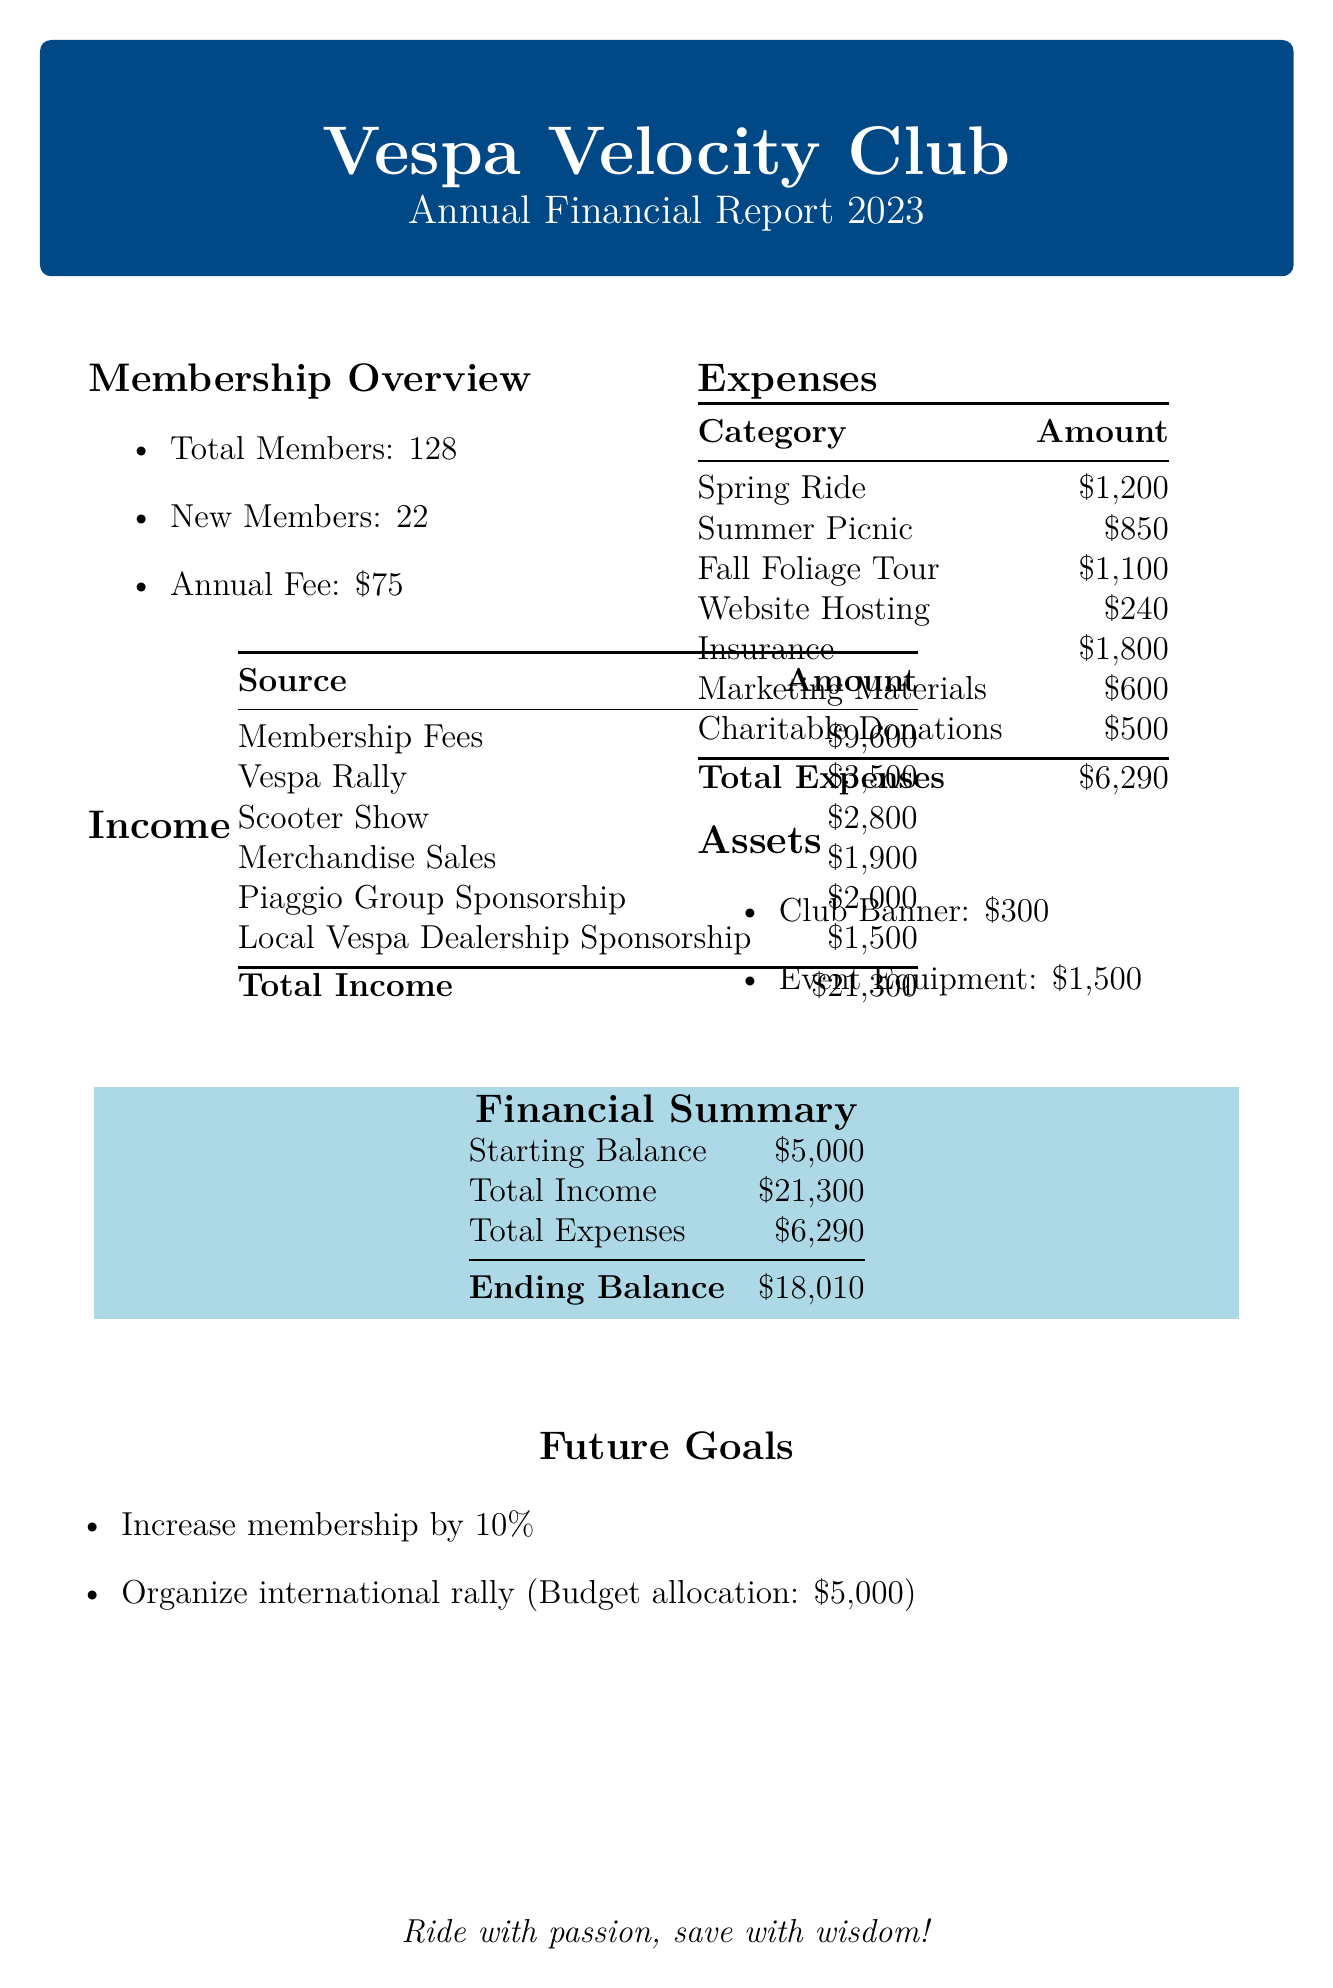What is the total number of members? The document states that the club has a total of 128 members.
Answer: 128 What was the annual fee for membership? The annual fee for membership, as mentioned in the document, is $75.
Answer: $75 How much was raised from fundraising events? The total amount raised from fundraising events is $8,200, which is the sum of Vespa Rally, Scooter Show, and Merchandise Sales.
Answer: $8,200 What was the total expense for events? The total expense for events is calculated by adding the costs of Spring Ride, Summer Picnic, and Fall Foliage Tour, which totals $3,150.
Answer: $3,150 What is the ending balance for the fiscal year? The ending balance at the end of the fiscal year is stated as $18,010.
Answer: $18,010 What is the budget allocation for the international rally? The document specifies that the budget allocation for organizing an international rally is $5,000.
Answer: $5,000 What was the total income for the club? The total income, calculated from all sources listed in the document, is $21,300.
Answer: $21,300 What is the total amount spent on club maintenance? The total spent on club maintenance, including Website Hosting, Insurance, and Marketing Materials, is $2,640.
Answer: $2,640 What is the goal for membership growth? The goal for membership growth is stated as a 10% increase.
Answer: 10% growth 